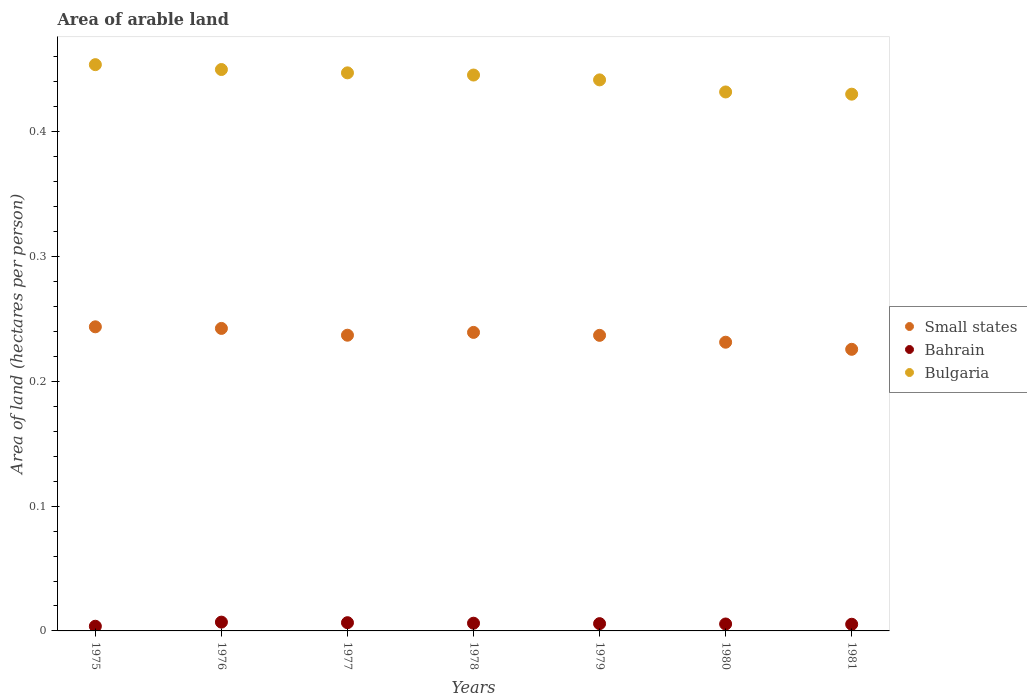How many different coloured dotlines are there?
Provide a short and direct response. 3. Is the number of dotlines equal to the number of legend labels?
Ensure brevity in your answer.  Yes. What is the total arable land in Bahrain in 1977?
Keep it short and to the point. 0.01. Across all years, what is the maximum total arable land in Small states?
Provide a succinct answer. 0.24. Across all years, what is the minimum total arable land in Bahrain?
Offer a very short reply. 0. In which year was the total arable land in Small states maximum?
Provide a succinct answer. 1975. In which year was the total arable land in Bulgaria minimum?
Ensure brevity in your answer.  1981. What is the total total arable land in Bulgaria in the graph?
Offer a very short reply. 3.1. What is the difference between the total arable land in Bahrain in 1980 and that in 1981?
Offer a terse response. 0. What is the difference between the total arable land in Bulgaria in 1979 and the total arable land in Small states in 1977?
Provide a short and direct response. 0.2. What is the average total arable land in Bulgaria per year?
Provide a short and direct response. 0.44. In the year 1975, what is the difference between the total arable land in Bahrain and total arable land in Bulgaria?
Make the answer very short. -0.45. What is the ratio of the total arable land in Bahrain in 1978 to that in 1981?
Provide a short and direct response. 1.16. Is the total arable land in Small states in 1979 less than that in 1980?
Ensure brevity in your answer.  No. Is the difference between the total arable land in Bahrain in 1978 and 1980 greater than the difference between the total arable land in Bulgaria in 1978 and 1980?
Your response must be concise. No. What is the difference between the highest and the second highest total arable land in Bulgaria?
Ensure brevity in your answer.  0. What is the difference between the highest and the lowest total arable land in Bulgaria?
Your response must be concise. 0.02. In how many years, is the total arable land in Small states greater than the average total arable land in Small states taken over all years?
Your response must be concise. 5. Does the total arable land in Small states monotonically increase over the years?
Offer a very short reply. No. Is the total arable land in Bahrain strictly less than the total arable land in Bulgaria over the years?
Provide a short and direct response. Yes. How many dotlines are there?
Offer a very short reply. 3. What is the difference between two consecutive major ticks on the Y-axis?
Keep it short and to the point. 0.1. Are the values on the major ticks of Y-axis written in scientific E-notation?
Your answer should be compact. No. Does the graph contain any zero values?
Offer a terse response. No. Does the graph contain grids?
Provide a short and direct response. No. Where does the legend appear in the graph?
Provide a succinct answer. Center right. How many legend labels are there?
Provide a succinct answer. 3. What is the title of the graph?
Your answer should be compact. Area of arable land. What is the label or title of the Y-axis?
Keep it short and to the point. Area of land (hectares per person). What is the Area of land (hectares per person) of Small states in 1975?
Make the answer very short. 0.24. What is the Area of land (hectares per person) of Bahrain in 1975?
Offer a very short reply. 0. What is the Area of land (hectares per person) in Bulgaria in 1975?
Make the answer very short. 0.45. What is the Area of land (hectares per person) in Small states in 1976?
Offer a very short reply. 0.24. What is the Area of land (hectares per person) in Bahrain in 1976?
Keep it short and to the point. 0.01. What is the Area of land (hectares per person) in Bulgaria in 1976?
Make the answer very short. 0.45. What is the Area of land (hectares per person) of Small states in 1977?
Your response must be concise. 0.24. What is the Area of land (hectares per person) of Bahrain in 1977?
Make the answer very short. 0.01. What is the Area of land (hectares per person) of Bulgaria in 1977?
Your response must be concise. 0.45. What is the Area of land (hectares per person) of Small states in 1978?
Provide a short and direct response. 0.24. What is the Area of land (hectares per person) of Bahrain in 1978?
Provide a short and direct response. 0.01. What is the Area of land (hectares per person) of Bulgaria in 1978?
Your answer should be very brief. 0.45. What is the Area of land (hectares per person) in Small states in 1979?
Offer a terse response. 0.24. What is the Area of land (hectares per person) of Bahrain in 1979?
Your answer should be very brief. 0.01. What is the Area of land (hectares per person) of Bulgaria in 1979?
Your answer should be compact. 0.44. What is the Area of land (hectares per person) of Small states in 1980?
Offer a terse response. 0.23. What is the Area of land (hectares per person) of Bahrain in 1980?
Give a very brief answer. 0.01. What is the Area of land (hectares per person) of Bulgaria in 1980?
Make the answer very short. 0.43. What is the Area of land (hectares per person) in Small states in 1981?
Give a very brief answer. 0.23. What is the Area of land (hectares per person) in Bahrain in 1981?
Offer a very short reply. 0.01. What is the Area of land (hectares per person) of Bulgaria in 1981?
Make the answer very short. 0.43. Across all years, what is the maximum Area of land (hectares per person) in Small states?
Offer a very short reply. 0.24. Across all years, what is the maximum Area of land (hectares per person) in Bahrain?
Your response must be concise. 0.01. Across all years, what is the maximum Area of land (hectares per person) in Bulgaria?
Your response must be concise. 0.45. Across all years, what is the minimum Area of land (hectares per person) of Small states?
Offer a very short reply. 0.23. Across all years, what is the minimum Area of land (hectares per person) in Bahrain?
Your answer should be very brief. 0. Across all years, what is the minimum Area of land (hectares per person) of Bulgaria?
Your answer should be compact. 0.43. What is the total Area of land (hectares per person) of Small states in the graph?
Offer a very short reply. 1.66. What is the total Area of land (hectares per person) of Bahrain in the graph?
Your answer should be very brief. 0.04. What is the total Area of land (hectares per person) in Bulgaria in the graph?
Ensure brevity in your answer.  3.1. What is the difference between the Area of land (hectares per person) in Small states in 1975 and that in 1976?
Your answer should be very brief. 0. What is the difference between the Area of land (hectares per person) of Bahrain in 1975 and that in 1976?
Your answer should be very brief. -0. What is the difference between the Area of land (hectares per person) in Bulgaria in 1975 and that in 1976?
Give a very brief answer. 0. What is the difference between the Area of land (hectares per person) in Small states in 1975 and that in 1977?
Your answer should be compact. 0.01. What is the difference between the Area of land (hectares per person) in Bahrain in 1975 and that in 1977?
Ensure brevity in your answer.  -0. What is the difference between the Area of land (hectares per person) of Bulgaria in 1975 and that in 1977?
Give a very brief answer. 0.01. What is the difference between the Area of land (hectares per person) of Small states in 1975 and that in 1978?
Offer a very short reply. 0. What is the difference between the Area of land (hectares per person) of Bahrain in 1975 and that in 1978?
Offer a terse response. -0. What is the difference between the Area of land (hectares per person) of Bulgaria in 1975 and that in 1978?
Keep it short and to the point. 0.01. What is the difference between the Area of land (hectares per person) in Small states in 1975 and that in 1979?
Provide a short and direct response. 0.01. What is the difference between the Area of land (hectares per person) in Bahrain in 1975 and that in 1979?
Your answer should be very brief. -0. What is the difference between the Area of land (hectares per person) of Bulgaria in 1975 and that in 1979?
Offer a terse response. 0.01. What is the difference between the Area of land (hectares per person) of Small states in 1975 and that in 1980?
Offer a very short reply. 0.01. What is the difference between the Area of land (hectares per person) in Bahrain in 1975 and that in 1980?
Give a very brief answer. -0. What is the difference between the Area of land (hectares per person) of Bulgaria in 1975 and that in 1980?
Make the answer very short. 0.02. What is the difference between the Area of land (hectares per person) of Small states in 1975 and that in 1981?
Provide a short and direct response. 0.02. What is the difference between the Area of land (hectares per person) of Bahrain in 1975 and that in 1981?
Give a very brief answer. -0. What is the difference between the Area of land (hectares per person) in Bulgaria in 1975 and that in 1981?
Ensure brevity in your answer.  0.02. What is the difference between the Area of land (hectares per person) of Small states in 1976 and that in 1977?
Your answer should be compact. 0.01. What is the difference between the Area of land (hectares per person) of Bulgaria in 1976 and that in 1977?
Your answer should be compact. 0. What is the difference between the Area of land (hectares per person) of Small states in 1976 and that in 1978?
Make the answer very short. 0. What is the difference between the Area of land (hectares per person) in Bahrain in 1976 and that in 1978?
Give a very brief answer. 0. What is the difference between the Area of land (hectares per person) in Bulgaria in 1976 and that in 1978?
Offer a terse response. 0. What is the difference between the Area of land (hectares per person) in Small states in 1976 and that in 1979?
Provide a succinct answer. 0.01. What is the difference between the Area of land (hectares per person) in Bahrain in 1976 and that in 1979?
Provide a short and direct response. 0. What is the difference between the Area of land (hectares per person) in Bulgaria in 1976 and that in 1979?
Make the answer very short. 0.01. What is the difference between the Area of land (hectares per person) of Small states in 1976 and that in 1980?
Your response must be concise. 0.01. What is the difference between the Area of land (hectares per person) in Bahrain in 1976 and that in 1980?
Provide a succinct answer. 0. What is the difference between the Area of land (hectares per person) in Bulgaria in 1976 and that in 1980?
Keep it short and to the point. 0.02. What is the difference between the Area of land (hectares per person) of Small states in 1976 and that in 1981?
Your answer should be compact. 0.02. What is the difference between the Area of land (hectares per person) of Bahrain in 1976 and that in 1981?
Ensure brevity in your answer.  0. What is the difference between the Area of land (hectares per person) of Bulgaria in 1976 and that in 1981?
Ensure brevity in your answer.  0.02. What is the difference between the Area of land (hectares per person) of Small states in 1977 and that in 1978?
Provide a short and direct response. -0. What is the difference between the Area of land (hectares per person) of Bulgaria in 1977 and that in 1978?
Offer a very short reply. 0. What is the difference between the Area of land (hectares per person) of Bahrain in 1977 and that in 1979?
Ensure brevity in your answer.  0. What is the difference between the Area of land (hectares per person) in Bulgaria in 1977 and that in 1979?
Keep it short and to the point. 0.01. What is the difference between the Area of land (hectares per person) in Small states in 1977 and that in 1980?
Offer a very short reply. 0.01. What is the difference between the Area of land (hectares per person) in Bahrain in 1977 and that in 1980?
Provide a succinct answer. 0. What is the difference between the Area of land (hectares per person) in Bulgaria in 1977 and that in 1980?
Give a very brief answer. 0.02. What is the difference between the Area of land (hectares per person) in Small states in 1977 and that in 1981?
Provide a succinct answer. 0.01. What is the difference between the Area of land (hectares per person) in Bahrain in 1977 and that in 1981?
Your answer should be compact. 0. What is the difference between the Area of land (hectares per person) in Bulgaria in 1977 and that in 1981?
Your answer should be compact. 0.02. What is the difference between the Area of land (hectares per person) of Small states in 1978 and that in 1979?
Make the answer very short. 0. What is the difference between the Area of land (hectares per person) of Bulgaria in 1978 and that in 1979?
Provide a short and direct response. 0. What is the difference between the Area of land (hectares per person) in Small states in 1978 and that in 1980?
Your response must be concise. 0.01. What is the difference between the Area of land (hectares per person) in Bahrain in 1978 and that in 1980?
Your response must be concise. 0. What is the difference between the Area of land (hectares per person) of Bulgaria in 1978 and that in 1980?
Your response must be concise. 0.01. What is the difference between the Area of land (hectares per person) in Small states in 1978 and that in 1981?
Keep it short and to the point. 0.01. What is the difference between the Area of land (hectares per person) of Bahrain in 1978 and that in 1981?
Your answer should be compact. 0. What is the difference between the Area of land (hectares per person) of Bulgaria in 1978 and that in 1981?
Your answer should be compact. 0.02. What is the difference between the Area of land (hectares per person) in Small states in 1979 and that in 1980?
Your answer should be compact. 0.01. What is the difference between the Area of land (hectares per person) of Bulgaria in 1979 and that in 1980?
Ensure brevity in your answer.  0.01. What is the difference between the Area of land (hectares per person) of Small states in 1979 and that in 1981?
Provide a succinct answer. 0.01. What is the difference between the Area of land (hectares per person) in Bahrain in 1979 and that in 1981?
Your answer should be compact. 0. What is the difference between the Area of land (hectares per person) in Bulgaria in 1979 and that in 1981?
Make the answer very short. 0.01. What is the difference between the Area of land (hectares per person) of Small states in 1980 and that in 1981?
Provide a short and direct response. 0.01. What is the difference between the Area of land (hectares per person) in Bahrain in 1980 and that in 1981?
Give a very brief answer. 0. What is the difference between the Area of land (hectares per person) in Bulgaria in 1980 and that in 1981?
Give a very brief answer. 0. What is the difference between the Area of land (hectares per person) in Small states in 1975 and the Area of land (hectares per person) in Bahrain in 1976?
Your answer should be compact. 0.24. What is the difference between the Area of land (hectares per person) of Small states in 1975 and the Area of land (hectares per person) of Bulgaria in 1976?
Offer a terse response. -0.21. What is the difference between the Area of land (hectares per person) of Bahrain in 1975 and the Area of land (hectares per person) of Bulgaria in 1976?
Ensure brevity in your answer.  -0.45. What is the difference between the Area of land (hectares per person) in Small states in 1975 and the Area of land (hectares per person) in Bahrain in 1977?
Provide a succinct answer. 0.24. What is the difference between the Area of land (hectares per person) of Small states in 1975 and the Area of land (hectares per person) of Bulgaria in 1977?
Offer a terse response. -0.2. What is the difference between the Area of land (hectares per person) in Bahrain in 1975 and the Area of land (hectares per person) in Bulgaria in 1977?
Make the answer very short. -0.44. What is the difference between the Area of land (hectares per person) in Small states in 1975 and the Area of land (hectares per person) in Bahrain in 1978?
Your answer should be compact. 0.24. What is the difference between the Area of land (hectares per person) of Small states in 1975 and the Area of land (hectares per person) of Bulgaria in 1978?
Ensure brevity in your answer.  -0.2. What is the difference between the Area of land (hectares per person) in Bahrain in 1975 and the Area of land (hectares per person) in Bulgaria in 1978?
Your answer should be very brief. -0.44. What is the difference between the Area of land (hectares per person) in Small states in 1975 and the Area of land (hectares per person) in Bahrain in 1979?
Your answer should be very brief. 0.24. What is the difference between the Area of land (hectares per person) of Small states in 1975 and the Area of land (hectares per person) of Bulgaria in 1979?
Ensure brevity in your answer.  -0.2. What is the difference between the Area of land (hectares per person) of Bahrain in 1975 and the Area of land (hectares per person) of Bulgaria in 1979?
Ensure brevity in your answer.  -0.44. What is the difference between the Area of land (hectares per person) in Small states in 1975 and the Area of land (hectares per person) in Bahrain in 1980?
Keep it short and to the point. 0.24. What is the difference between the Area of land (hectares per person) of Small states in 1975 and the Area of land (hectares per person) of Bulgaria in 1980?
Your answer should be compact. -0.19. What is the difference between the Area of land (hectares per person) of Bahrain in 1975 and the Area of land (hectares per person) of Bulgaria in 1980?
Your response must be concise. -0.43. What is the difference between the Area of land (hectares per person) of Small states in 1975 and the Area of land (hectares per person) of Bahrain in 1981?
Keep it short and to the point. 0.24. What is the difference between the Area of land (hectares per person) of Small states in 1975 and the Area of land (hectares per person) of Bulgaria in 1981?
Your answer should be very brief. -0.19. What is the difference between the Area of land (hectares per person) of Bahrain in 1975 and the Area of land (hectares per person) of Bulgaria in 1981?
Keep it short and to the point. -0.43. What is the difference between the Area of land (hectares per person) in Small states in 1976 and the Area of land (hectares per person) in Bahrain in 1977?
Your response must be concise. 0.24. What is the difference between the Area of land (hectares per person) of Small states in 1976 and the Area of land (hectares per person) of Bulgaria in 1977?
Your answer should be very brief. -0.2. What is the difference between the Area of land (hectares per person) in Bahrain in 1976 and the Area of land (hectares per person) in Bulgaria in 1977?
Make the answer very short. -0.44. What is the difference between the Area of land (hectares per person) of Small states in 1976 and the Area of land (hectares per person) of Bahrain in 1978?
Offer a terse response. 0.24. What is the difference between the Area of land (hectares per person) of Small states in 1976 and the Area of land (hectares per person) of Bulgaria in 1978?
Give a very brief answer. -0.2. What is the difference between the Area of land (hectares per person) of Bahrain in 1976 and the Area of land (hectares per person) of Bulgaria in 1978?
Keep it short and to the point. -0.44. What is the difference between the Area of land (hectares per person) in Small states in 1976 and the Area of land (hectares per person) in Bahrain in 1979?
Give a very brief answer. 0.24. What is the difference between the Area of land (hectares per person) of Small states in 1976 and the Area of land (hectares per person) of Bulgaria in 1979?
Your answer should be compact. -0.2. What is the difference between the Area of land (hectares per person) in Bahrain in 1976 and the Area of land (hectares per person) in Bulgaria in 1979?
Your response must be concise. -0.43. What is the difference between the Area of land (hectares per person) in Small states in 1976 and the Area of land (hectares per person) in Bahrain in 1980?
Offer a very short reply. 0.24. What is the difference between the Area of land (hectares per person) of Small states in 1976 and the Area of land (hectares per person) of Bulgaria in 1980?
Your answer should be compact. -0.19. What is the difference between the Area of land (hectares per person) of Bahrain in 1976 and the Area of land (hectares per person) of Bulgaria in 1980?
Your answer should be compact. -0.42. What is the difference between the Area of land (hectares per person) in Small states in 1976 and the Area of land (hectares per person) in Bahrain in 1981?
Keep it short and to the point. 0.24. What is the difference between the Area of land (hectares per person) in Small states in 1976 and the Area of land (hectares per person) in Bulgaria in 1981?
Provide a short and direct response. -0.19. What is the difference between the Area of land (hectares per person) in Bahrain in 1976 and the Area of land (hectares per person) in Bulgaria in 1981?
Your answer should be compact. -0.42. What is the difference between the Area of land (hectares per person) in Small states in 1977 and the Area of land (hectares per person) in Bahrain in 1978?
Ensure brevity in your answer.  0.23. What is the difference between the Area of land (hectares per person) of Small states in 1977 and the Area of land (hectares per person) of Bulgaria in 1978?
Ensure brevity in your answer.  -0.21. What is the difference between the Area of land (hectares per person) of Bahrain in 1977 and the Area of land (hectares per person) of Bulgaria in 1978?
Your response must be concise. -0.44. What is the difference between the Area of land (hectares per person) of Small states in 1977 and the Area of land (hectares per person) of Bahrain in 1979?
Give a very brief answer. 0.23. What is the difference between the Area of land (hectares per person) of Small states in 1977 and the Area of land (hectares per person) of Bulgaria in 1979?
Keep it short and to the point. -0.2. What is the difference between the Area of land (hectares per person) in Bahrain in 1977 and the Area of land (hectares per person) in Bulgaria in 1979?
Provide a short and direct response. -0.43. What is the difference between the Area of land (hectares per person) of Small states in 1977 and the Area of land (hectares per person) of Bahrain in 1980?
Your answer should be very brief. 0.23. What is the difference between the Area of land (hectares per person) in Small states in 1977 and the Area of land (hectares per person) in Bulgaria in 1980?
Offer a very short reply. -0.19. What is the difference between the Area of land (hectares per person) of Bahrain in 1977 and the Area of land (hectares per person) of Bulgaria in 1980?
Your answer should be very brief. -0.43. What is the difference between the Area of land (hectares per person) in Small states in 1977 and the Area of land (hectares per person) in Bahrain in 1981?
Give a very brief answer. 0.23. What is the difference between the Area of land (hectares per person) of Small states in 1977 and the Area of land (hectares per person) of Bulgaria in 1981?
Provide a short and direct response. -0.19. What is the difference between the Area of land (hectares per person) in Bahrain in 1977 and the Area of land (hectares per person) in Bulgaria in 1981?
Your answer should be very brief. -0.42. What is the difference between the Area of land (hectares per person) in Small states in 1978 and the Area of land (hectares per person) in Bahrain in 1979?
Your response must be concise. 0.23. What is the difference between the Area of land (hectares per person) of Small states in 1978 and the Area of land (hectares per person) of Bulgaria in 1979?
Provide a short and direct response. -0.2. What is the difference between the Area of land (hectares per person) of Bahrain in 1978 and the Area of land (hectares per person) of Bulgaria in 1979?
Your answer should be very brief. -0.44. What is the difference between the Area of land (hectares per person) in Small states in 1978 and the Area of land (hectares per person) in Bahrain in 1980?
Ensure brevity in your answer.  0.23. What is the difference between the Area of land (hectares per person) of Small states in 1978 and the Area of land (hectares per person) of Bulgaria in 1980?
Ensure brevity in your answer.  -0.19. What is the difference between the Area of land (hectares per person) in Bahrain in 1978 and the Area of land (hectares per person) in Bulgaria in 1980?
Offer a terse response. -0.43. What is the difference between the Area of land (hectares per person) of Small states in 1978 and the Area of land (hectares per person) of Bahrain in 1981?
Offer a very short reply. 0.23. What is the difference between the Area of land (hectares per person) of Small states in 1978 and the Area of land (hectares per person) of Bulgaria in 1981?
Provide a succinct answer. -0.19. What is the difference between the Area of land (hectares per person) in Bahrain in 1978 and the Area of land (hectares per person) in Bulgaria in 1981?
Offer a very short reply. -0.42. What is the difference between the Area of land (hectares per person) of Small states in 1979 and the Area of land (hectares per person) of Bahrain in 1980?
Make the answer very short. 0.23. What is the difference between the Area of land (hectares per person) of Small states in 1979 and the Area of land (hectares per person) of Bulgaria in 1980?
Your answer should be very brief. -0.2. What is the difference between the Area of land (hectares per person) of Bahrain in 1979 and the Area of land (hectares per person) of Bulgaria in 1980?
Provide a short and direct response. -0.43. What is the difference between the Area of land (hectares per person) in Small states in 1979 and the Area of land (hectares per person) in Bahrain in 1981?
Provide a succinct answer. 0.23. What is the difference between the Area of land (hectares per person) of Small states in 1979 and the Area of land (hectares per person) of Bulgaria in 1981?
Make the answer very short. -0.19. What is the difference between the Area of land (hectares per person) in Bahrain in 1979 and the Area of land (hectares per person) in Bulgaria in 1981?
Give a very brief answer. -0.42. What is the difference between the Area of land (hectares per person) in Small states in 1980 and the Area of land (hectares per person) in Bahrain in 1981?
Offer a terse response. 0.23. What is the difference between the Area of land (hectares per person) of Small states in 1980 and the Area of land (hectares per person) of Bulgaria in 1981?
Make the answer very short. -0.2. What is the difference between the Area of land (hectares per person) of Bahrain in 1980 and the Area of land (hectares per person) of Bulgaria in 1981?
Give a very brief answer. -0.42. What is the average Area of land (hectares per person) in Small states per year?
Keep it short and to the point. 0.24. What is the average Area of land (hectares per person) in Bahrain per year?
Provide a succinct answer. 0.01. What is the average Area of land (hectares per person) of Bulgaria per year?
Ensure brevity in your answer.  0.44. In the year 1975, what is the difference between the Area of land (hectares per person) in Small states and Area of land (hectares per person) in Bahrain?
Your response must be concise. 0.24. In the year 1975, what is the difference between the Area of land (hectares per person) in Small states and Area of land (hectares per person) in Bulgaria?
Your answer should be very brief. -0.21. In the year 1975, what is the difference between the Area of land (hectares per person) of Bahrain and Area of land (hectares per person) of Bulgaria?
Your answer should be very brief. -0.45. In the year 1976, what is the difference between the Area of land (hectares per person) of Small states and Area of land (hectares per person) of Bahrain?
Offer a very short reply. 0.24. In the year 1976, what is the difference between the Area of land (hectares per person) in Small states and Area of land (hectares per person) in Bulgaria?
Your answer should be very brief. -0.21. In the year 1976, what is the difference between the Area of land (hectares per person) in Bahrain and Area of land (hectares per person) in Bulgaria?
Your response must be concise. -0.44. In the year 1977, what is the difference between the Area of land (hectares per person) in Small states and Area of land (hectares per person) in Bahrain?
Keep it short and to the point. 0.23. In the year 1977, what is the difference between the Area of land (hectares per person) of Small states and Area of land (hectares per person) of Bulgaria?
Keep it short and to the point. -0.21. In the year 1977, what is the difference between the Area of land (hectares per person) of Bahrain and Area of land (hectares per person) of Bulgaria?
Make the answer very short. -0.44. In the year 1978, what is the difference between the Area of land (hectares per person) in Small states and Area of land (hectares per person) in Bahrain?
Your answer should be compact. 0.23. In the year 1978, what is the difference between the Area of land (hectares per person) of Small states and Area of land (hectares per person) of Bulgaria?
Provide a short and direct response. -0.21. In the year 1978, what is the difference between the Area of land (hectares per person) of Bahrain and Area of land (hectares per person) of Bulgaria?
Offer a terse response. -0.44. In the year 1979, what is the difference between the Area of land (hectares per person) in Small states and Area of land (hectares per person) in Bahrain?
Your answer should be very brief. 0.23. In the year 1979, what is the difference between the Area of land (hectares per person) in Small states and Area of land (hectares per person) in Bulgaria?
Provide a short and direct response. -0.2. In the year 1979, what is the difference between the Area of land (hectares per person) in Bahrain and Area of land (hectares per person) in Bulgaria?
Ensure brevity in your answer.  -0.44. In the year 1980, what is the difference between the Area of land (hectares per person) in Small states and Area of land (hectares per person) in Bahrain?
Provide a succinct answer. 0.23. In the year 1980, what is the difference between the Area of land (hectares per person) in Small states and Area of land (hectares per person) in Bulgaria?
Your answer should be very brief. -0.2. In the year 1980, what is the difference between the Area of land (hectares per person) of Bahrain and Area of land (hectares per person) of Bulgaria?
Give a very brief answer. -0.43. In the year 1981, what is the difference between the Area of land (hectares per person) of Small states and Area of land (hectares per person) of Bahrain?
Offer a terse response. 0.22. In the year 1981, what is the difference between the Area of land (hectares per person) in Small states and Area of land (hectares per person) in Bulgaria?
Make the answer very short. -0.2. In the year 1981, what is the difference between the Area of land (hectares per person) in Bahrain and Area of land (hectares per person) in Bulgaria?
Your answer should be very brief. -0.42. What is the ratio of the Area of land (hectares per person) in Small states in 1975 to that in 1976?
Provide a short and direct response. 1.01. What is the ratio of the Area of land (hectares per person) in Bahrain in 1975 to that in 1976?
Keep it short and to the point. 0.53. What is the ratio of the Area of land (hectares per person) of Bulgaria in 1975 to that in 1976?
Provide a short and direct response. 1.01. What is the ratio of the Area of land (hectares per person) of Small states in 1975 to that in 1977?
Offer a very short reply. 1.03. What is the ratio of the Area of land (hectares per person) of Bahrain in 1975 to that in 1977?
Provide a succinct answer. 0.57. What is the ratio of the Area of land (hectares per person) in Bulgaria in 1975 to that in 1977?
Provide a short and direct response. 1.01. What is the ratio of the Area of land (hectares per person) of Small states in 1975 to that in 1978?
Ensure brevity in your answer.  1.02. What is the ratio of the Area of land (hectares per person) in Bahrain in 1975 to that in 1978?
Give a very brief answer. 0.61. What is the ratio of the Area of land (hectares per person) in Bulgaria in 1975 to that in 1978?
Ensure brevity in your answer.  1.02. What is the ratio of the Area of land (hectares per person) of Small states in 1975 to that in 1979?
Provide a succinct answer. 1.03. What is the ratio of the Area of land (hectares per person) in Bahrain in 1975 to that in 1979?
Give a very brief answer. 0.64. What is the ratio of the Area of land (hectares per person) of Bulgaria in 1975 to that in 1979?
Keep it short and to the point. 1.03. What is the ratio of the Area of land (hectares per person) of Small states in 1975 to that in 1980?
Your answer should be compact. 1.05. What is the ratio of the Area of land (hectares per person) of Bahrain in 1975 to that in 1980?
Your answer should be very brief. 0.67. What is the ratio of the Area of land (hectares per person) of Bulgaria in 1975 to that in 1980?
Your response must be concise. 1.05. What is the ratio of the Area of land (hectares per person) of Small states in 1975 to that in 1981?
Your answer should be very brief. 1.08. What is the ratio of the Area of land (hectares per person) in Bahrain in 1975 to that in 1981?
Offer a very short reply. 0.7. What is the ratio of the Area of land (hectares per person) of Bulgaria in 1975 to that in 1981?
Provide a short and direct response. 1.05. What is the ratio of the Area of land (hectares per person) in Bahrain in 1976 to that in 1977?
Offer a terse response. 1.07. What is the ratio of the Area of land (hectares per person) of Bulgaria in 1976 to that in 1977?
Your answer should be very brief. 1.01. What is the ratio of the Area of land (hectares per person) in Small states in 1976 to that in 1978?
Offer a terse response. 1.01. What is the ratio of the Area of land (hectares per person) in Bahrain in 1976 to that in 1978?
Offer a very short reply. 1.14. What is the ratio of the Area of land (hectares per person) of Bulgaria in 1976 to that in 1978?
Provide a short and direct response. 1.01. What is the ratio of the Area of land (hectares per person) of Small states in 1976 to that in 1979?
Make the answer very short. 1.02. What is the ratio of the Area of land (hectares per person) in Bahrain in 1976 to that in 1979?
Your answer should be very brief. 1.21. What is the ratio of the Area of land (hectares per person) in Bulgaria in 1976 to that in 1979?
Keep it short and to the point. 1.02. What is the ratio of the Area of land (hectares per person) in Small states in 1976 to that in 1980?
Make the answer very short. 1.05. What is the ratio of the Area of land (hectares per person) in Bahrain in 1976 to that in 1980?
Provide a short and direct response. 1.27. What is the ratio of the Area of land (hectares per person) of Bulgaria in 1976 to that in 1980?
Make the answer very short. 1.04. What is the ratio of the Area of land (hectares per person) in Small states in 1976 to that in 1981?
Offer a terse response. 1.07. What is the ratio of the Area of land (hectares per person) of Bahrain in 1976 to that in 1981?
Give a very brief answer. 1.32. What is the ratio of the Area of land (hectares per person) of Bulgaria in 1976 to that in 1981?
Offer a terse response. 1.05. What is the ratio of the Area of land (hectares per person) in Small states in 1977 to that in 1978?
Provide a succinct answer. 0.99. What is the ratio of the Area of land (hectares per person) of Bahrain in 1977 to that in 1978?
Give a very brief answer. 1.07. What is the ratio of the Area of land (hectares per person) in Bahrain in 1977 to that in 1979?
Provide a succinct answer. 1.13. What is the ratio of the Area of land (hectares per person) in Bulgaria in 1977 to that in 1979?
Your answer should be compact. 1.01. What is the ratio of the Area of land (hectares per person) of Small states in 1977 to that in 1980?
Offer a very short reply. 1.02. What is the ratio of the Area of land (hectares per person) in Bahrain in 1977 to that in 1980?
Offer a terse response. 1.19. What is the ratio of the Area of land (hectares per person) in Bulgaria in 1977 to that in 1980?
Provide a succinct answer. 1.04. What is the ratio of the Area of land (hectares per person) of Small states in 1977 to that in 1981?
Ensure brevity in your answer.  1.05. What is the ratio of the Area of land (hectares per person) in Bahrain in 1977 to that in 1981?
Offer a very short reply. 1.23. What is the ratio of the Area of land (hectares per person) of Bulgaria in 1977 to that in 1981?
Keep it short and to the point. 1.04. What is the ratio of the Area of land (hectares per person) of Bahrain in 1978 to that in 1979?
Ensure brevity in your answer.  1.06. What is the ratio of the Area of land (hectares per person) in Bulgaria in 1978 to that in 1979?
Provide a short and direct response. 1.01. What is the ratio of the Area of land (hectares per person) of Small states in 1978 to that in 1980?
Your answer should be very brief. 1.03. What is the ratio of the Area of land (hectares per person) of Bahrain in 1978 to that in 1980?
Your response must be concise. 1.11. What is the ratio of the Area of land (hectares per person) in Bulgaria in 1978 to that in 1980?
Your answer should be very brief. 1.03. What is the ratio of the Area of land (hectares per person) of Small states in 1978 to that in 1981?
Keep it short and to the point. 1.06. What is the ratio of the Area of land (hectares per person) in Bahrain in 1978 to that in 1981?
Provide a succinct answer. 1.16. What is the ratio of the Area of land (hectares per person) in Bulgaria in 1978 to that in 1981?
Make the answer very short. 1.04. What is the ratio of the Area of land (hectares per person) of Small states in 1979 to that in 1980?
Offer a very short reply. 1.02. What is the ratio of the Area of land (hectares per person) of Bahrain in 1979 to that in 1980?
Offer a terse response. 1.05. What is the ratio of the Area of land (hectares per person) of Bulgaria in 1979 to that in 1980?
Give a very brief answer. 1.02. What is the ratio of the Area of land (hectares per person) in Small states in 1979 to that in 1981?
Offer a terse response. 1.05. What is the ratio of the Area of land (hectares per person) of Bahrain in 1979 to that in 1981?
Your response must be concise. 1.09. What is the ratio of the Area of land (hectares per person) in Bulgaria in 1979 to that in 1981?
Offer a very short reply. 1.03. What is the ratio of the Area of land (hectares per person) in Small states in 1980 to that in 1981?
Provide a succinct answer. 1.03. What is the ratio of the Area of land (hectares per person) of Bahrain in 1980 to that in 1981?
Make the answer very short. 1.04. What is the difference between the highest and the second highest Area of land (hectares per person) in Small states?
Your response must be concise. 0. What is the difference between the highest and the second highest Area of land (hectares per person) in Bahrain?
Provide a succinct answer. 0. What is the difference between the highest and the second highest Area of land (hectares per person) in Bulgaria?
Your response must be concise. 0. What is the difference between the highest and the lowest Area of land (hectares per person) of Small states?
Your response must be concise. 0.02. What is the difference between the highest and the lowest Area of land (hectares per person) of Bahrain?
Your response must be concise. 0. What is the difference between the highest and the lowest Area of land (hectares per person) of Bulgaria?
Provide a short and direct response. 0.02. 